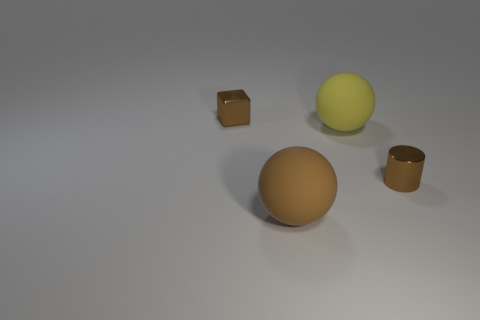Subtract all blocks. How many objects are left? 3 Add 1 cylinders. How many objects exist? 5 Add 4 large objects. How many large objects exist? 6 Subtract 0 yellow cylinders. How many objects are left? 4 Subtract all brown rubber objects. Subtract all big yellow matte spheres. How many objects are left? 2 Add 4 large brown rubber balls. How many large brown rubber balls are left? 5 